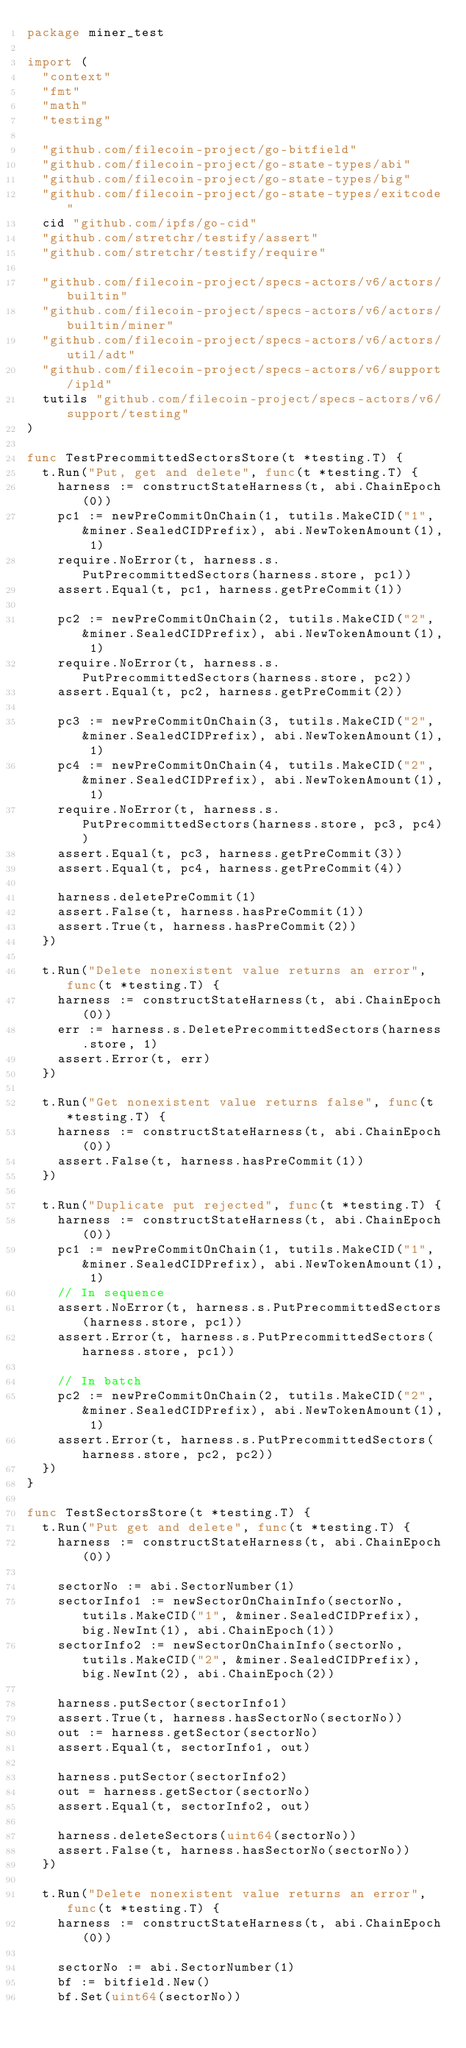<code> <loc_0><loc_0><loc_500><loc_500><_Go_>package miner_test

import (
	"context"
	"fmt"
	"math"
	"testing"

	"github.com/filecoin-project/go-bitfield"
	"github.com/filecoin-project/go-state-types/abi"
	"github.com/filecoin-project/go-state-types/big"
	"github.com/filecoin-project/go-state-types/exitcode"
	cid "github.com/ipfs/go-cid"
	"github.com/stretchr/testify/assert"
	"github.com/stretchr/testify/require"

	"github.com/filecoin-project/specs-actors/v6/actors/builtin"
	"github.com/filecoin-project/specs-actors/v6/actors/builtin/miner"
	"github.com/filecoin-project/specs-actors/v6/actors/util/adt"
	"github.com/filecoin-project/specs-actors/v6/support/ipld"
	tutils "github.com/filecoin-project/specs-actors/v6/support/testing"
)

func TestPrecommittedSectorsStore(t *testing.T) {
	t.Run("Put, get and delete", func(t *testing.T) {
		harness := constructStateHarness(t, abi.ChainEpoch(0))
		pc1 := newPreCommitOnChain(1, tutils.MakeCID("1", &miner.SealedCIDPrefix), abi.NewTokenAmount(1), 1)
		require.NoError(t, harness.s.PutPrecommittedSectors(harness.store, pc1))
		assert.Equal(t, pc1, harness.getPreCommit(1))

		pc2 := newPreCommitOnChain(2, tutils.MakeCID("2", &miner.SealedCIDPrefix), abi.NewTokenAmount(1), 1)
		require.NoError(t, harness.s.PutPrecommittedSectors(harness.store, pc2))
		assert.Equal(t, pc2, harness.getPreCommit(2))

		pc3 := newPreCommitOnChain(3, tutils.MakeCID("2", &miner.SealedCIDPrefix), abi.NewTokenAmount(1), 1)
		pc4 := newPreCommitOnChain(4, tutils.MakeCID("2", &miner.SealedCIDPrefix), abi.NewTokenAmount(1), 1)
		require.NoError(t, harness.s.PutPrecommittedSectors(harness.store, pc3, pc4))
		assert.Equal(t, pc3, harness.getPreCommit(3))
		assert.Equal(t, pc4, harness.getPreCommit(4))

		harness.deletePreCommit(1)
		assert.False(t, harness.hasPreCommit(1))
		assert.True(t, harness.hasPreCommit(2))
	})

	t.Run("Delete nonexistent value returns an error", func(t *testing.T) {
		harness := constructStateHarness(t, abi.ChainEpoch(0))
		err := harness.s.DeletePrecommittedSectors(harness.store, 1)
		assert.Error(t, err)
	})

	t.Run("Get nonexistent value returns false", func(t *testing.T) {
		harness := constructStateHarness(t, abi.ChainEpoch(0))
		assert.False(t, harness.hasPreCommit(1))
	})

	t.Run("Duplicate put rejected", func(t *testing.T) {
		harness := constructStateHarness(t, abi.ChainEpoch(0))
		pc1 := newPreCommitOnChain(1, tutils.MakeCID("1", &miner.SealedCIDPrefix), abi.NewTokenAmount(1), 1)
		// In sequence
		assert.NoError(t, harness.s.PutPrecommittedSectors(harness.store, pc1))
		assert.Error(t, harness.s.PutPrecommittedSectors(harness.store, pc1))

		// In batch
		pc2 := newPreCommitOnChain(2, tutils.MakeCID("2", &miner.SealedCIDPrefix), abi.NewTokenAmount(1), 1)
		assert.Error(t, harness.s.PutPrecommittedSectors(harness.store, pc2, pc2))
	})
}

func TestSectorsStore(t *testing.T) {
	t.Run("Put get and delete", func(t *testing.T) {
		harness := constructStateHarness(t, abi.ChainEpoch(0))

		sectorNo := abi.SectorNumber(1)
		sectorInfo1 := newSectorOnChainInfo(sectorNo, tutils.MakeCID("1", &miner.SealedCIDPrefix), big.NewInt(1), abi.ChainEpoch(1))
		sectorInfo2 := newSectorOnChainInfo(sectorNo, tutils.MakeCID("2", &miner.SealedCIDPrefix), big.NewInt(2), abi.ChainEpoch(2))

		harness.putSector(sectorInfo1)
		assert.True(t, harness.hasSectorNo(sectorNo))
		out := harness.getSector(sectorNo)
		assert.Equal(t, sectorInfo1, out)

		harness.putSector(sectorInfo2)
		out = harness.getSector(sectorNo)
		assert.Equal(t, sectorInfo2, out)

		harness.deleteSectors(uint64(sectorNo))
		assert.False(t, harness.hasSectorNo(sectorNo))
	})

	t.Run("Delete nonexistent value returns an error", func(t *testing.T) {
		harness := constructStateHarness(t, abi.ChainEpoch(0))

		sectorNo := abi.SectorNumber(1)
		bf := bitfield.New()
		bf.Set(uint64(sectorNo))
</code> 